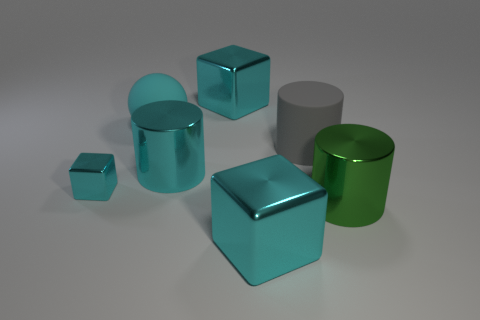Can you describe the texture differences among the objects shown? Certainly. The objects exhibit a variety of textures. The large and small matte balls have a uniformly diffused appearance with no reflections, giving them a soft, non-reflective texture. Conversely, the cyan and green metallic objects have a glossy finish with sharp reflections, indicating a smooth and shiny texture. The gray rubber cylinder has a satin-like texture, somewhat reflective but not as polished as the metallic objects. Which objects appear to reflect light more intensely? The cyan and green metallic objects reflect light more intensely. Their surfaces are highly reflective, with clear and bright highlights that indicate a glossy finish, capturing and reflecting much of the ambient light in the scene. 